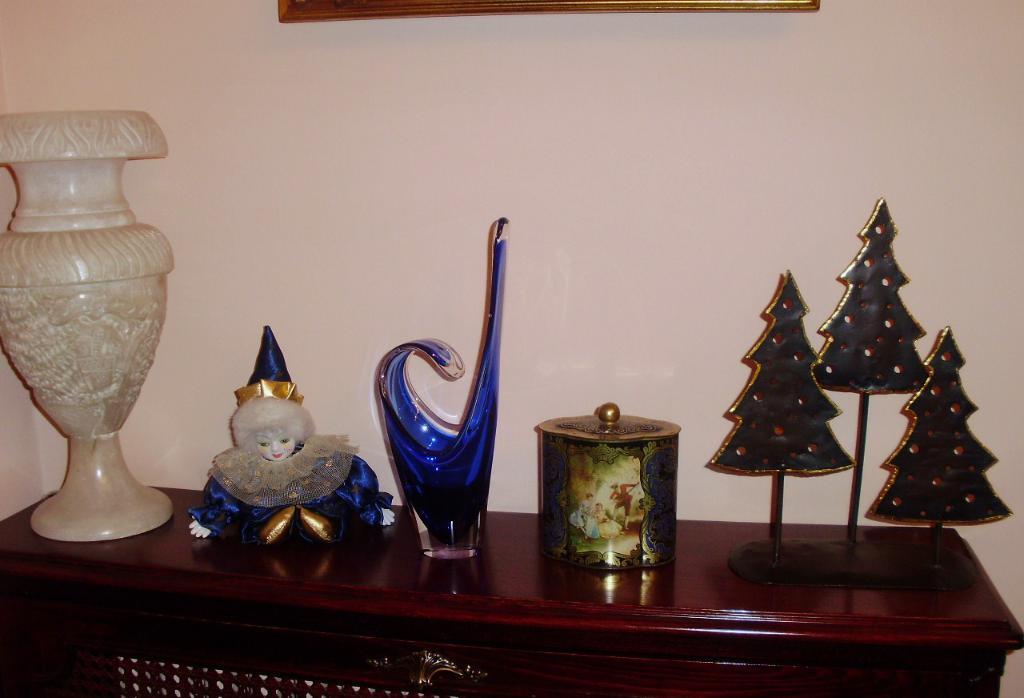Describe this image in one or two sentences. This picture is clicked inside the room. Here, we see a brown table on which vase, jar, photo frame, doll and plastic trees are placed. Behind that, we see a white wall on which photo frame is placed. 